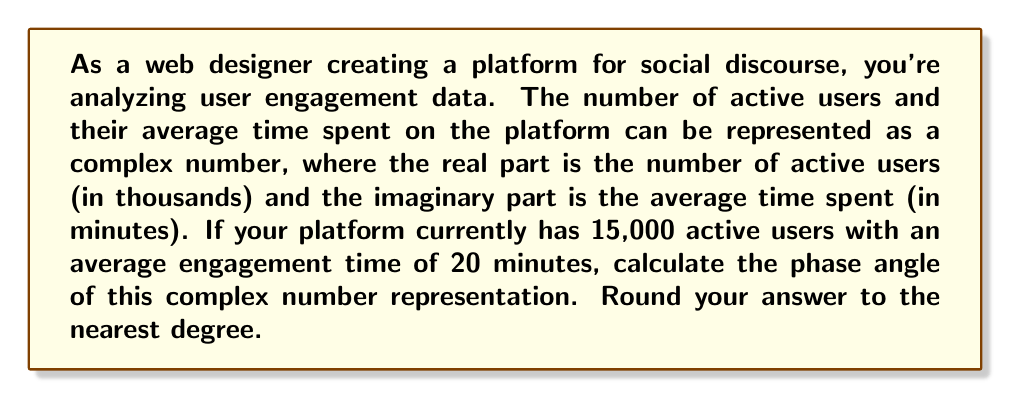Can you solve this math problem? To solve this problem, we need to follow these steps:

1) First, let's represent our data as a complex number. We have:
   $z = 15 + 20i$
   (15 thousand users and 20 minutes average time)

2) The phase angle $\theta$ of a complex number $z = a + bi$ is given by the formula:
   $$\theta = \arctan(\frac{b}{a})$$

3) In our case, $a = 15$ and $b = 20$. Let's substitute these values:
   $$\theta = \arctan(\frac{20}{15})$$

4) To calculate this:
   $$\theta = \arctan(1.3333...)$$

5) Using a calculator or computer, we can evaluate this:
   $$\theta \approx 53.13010235415598^\circ$$

6) Rounding to the nearest degree:
   $$\theta \approx 53^\circ$$

This angle represents the relationship between the number of users and their engagement time. A larger angle would indicate relatively higher engagement time compared to the number of users, while a smaller angle would indicate the opposite.
Answer: $53^\circ$ 